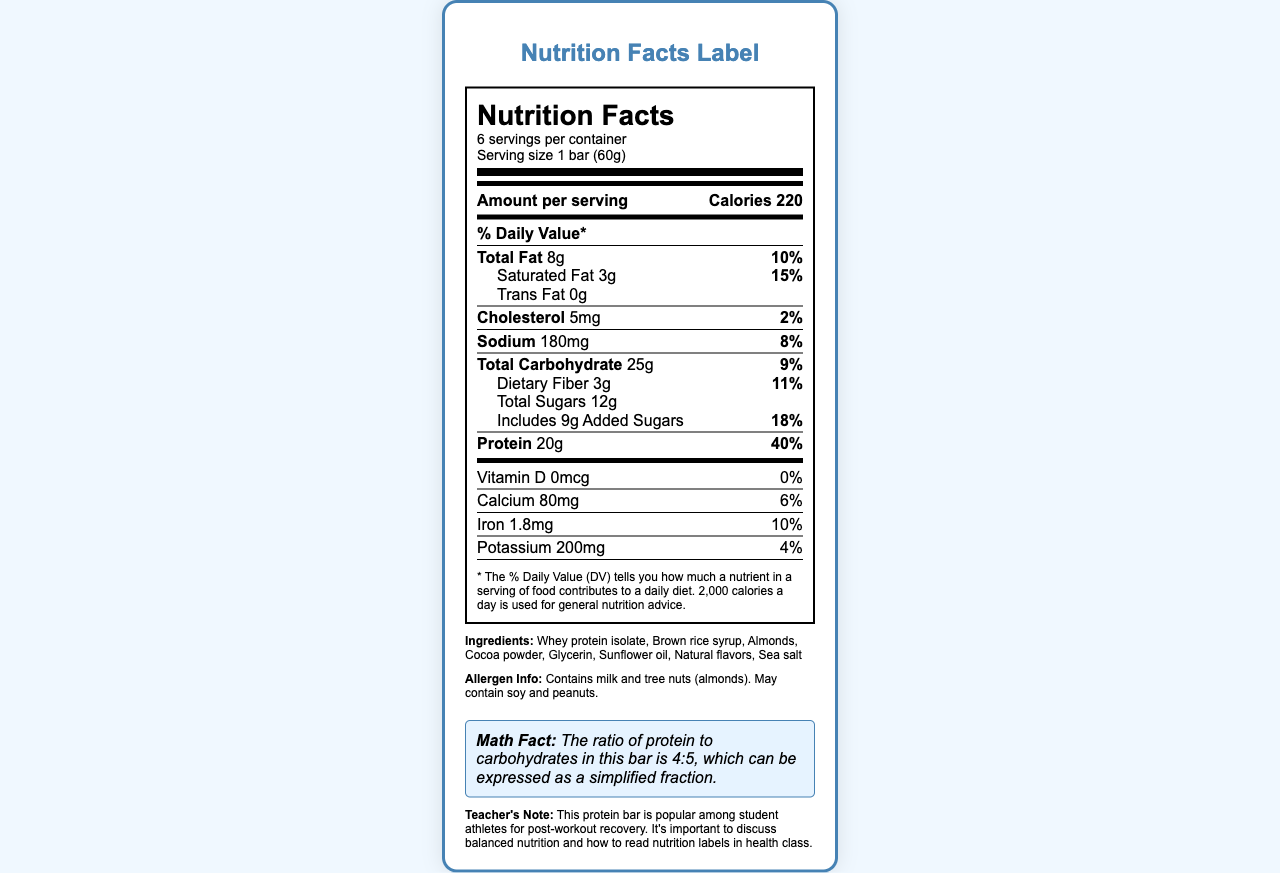what is the name of the product? The name of the product is clearly stated at the beginning of the document under "product_name".
Answer: PowerUp Pro Protein Bar how many calories are in one serving of the protein bar? According to the document, each serving of the PowerUp Pro Protein Bar contains 220 calories.
Answer: 220 what is the serving size of the protein bar? The serving size is specified as "1 bar (60g)" in the document under "serving_size".
Answer: 1 bar (60g) how many grams of saturated fat are in the protein bar? The document lists the amount of saturated fat as "3g".
Answer: 3g what is the % Daily Value of protein per serving? The % Daily Value of protein per serving is indicated as "40%" in the document.
Answer: 40% how many servings are there per container? The document specifies that there are 6 servings per container.
Answer: 6 what is the ratio of protein to carbohydrates in the protein bar? A. 1:4 B. 4:5 C. 2:3 The document provides a math fact stating that the ratio of protein to carbohydrates is 4:5.
Answer: B. 4:5 how much calcium does the protein bar contain? A. 60mg B. 120mg C. 80mg D. 100mg It is specified in the document that the protein bar contains 80mg of calcium.
Answer: C. 80mg does the protein bar contain any trans fat? According to the document, the trans fat content is listed as "0g" which means the protein bar does not contain any trans fat.
Answer: No is the document providing nutrition facts for a drink? The document describes the nutrition facts for a protein bar, not a drink.
Answer: No summarize the document. The concise summary includes the main points like product name, serving size, nutrient content, ingredients, allergen info, and an interesting math fact.
Answer: The document provides detailed nutrition information for the "PowerUp Pro Protein Bar." It includes the serving size, calories per serving, amounts and daily values for various nutrients such as fat, cholesterol, sodium, carbohydrates, protein, vitamins, minerals, and ingredients. It also mentions allergen information and a math fact relating to the ratio of protein to carbohydrates. what is the price of the protein bar? The document does not provide any information regarding the price of the protein bar.
Answer: Not enough information 